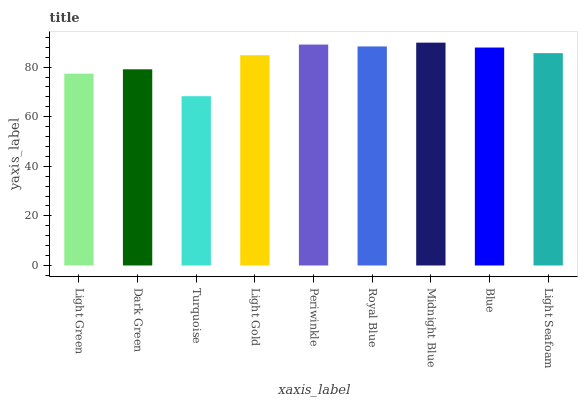Is Turquoise the minimum?
Answer yes or no. Yes. Is Midnight Blue the maximum?
Answer yes or no. Yes. Is Dark Green the minimum?
Answer yes or no. No. Is Dark Green the maximum?
Answer yes or no. No. Is Dark Green greater than Light Green?
Answer yes or no. Yes. Is Light Green less than Dark Green?
Answer yes or no. Yes. Is Light Green greater than Dark Green?
Answer yes or no. No. Is Dark Green less than Light Green?
Answer yes or no. No. Is Light Seafoam the high median?
Answer yes or no. Yes. Is Light Seafoam the low median?
Answer yes or no. Yes. Is Light Green the high median?
Answer yes or no. No. Is Light Green the low median?
Answer yes or no. No. 